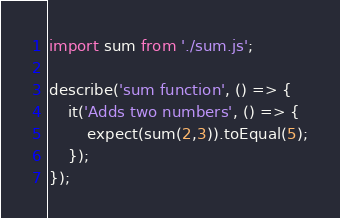Convert code to text. <code><loc_0><loc_0><loc_500><loc_500><_JavaScript_>import sum from './sum.js';
 
describe('sum function', () => {
    it('Adds two numbers', () => {
        expect(sum(2,3)).toEqual(5);
    });
});</code> 